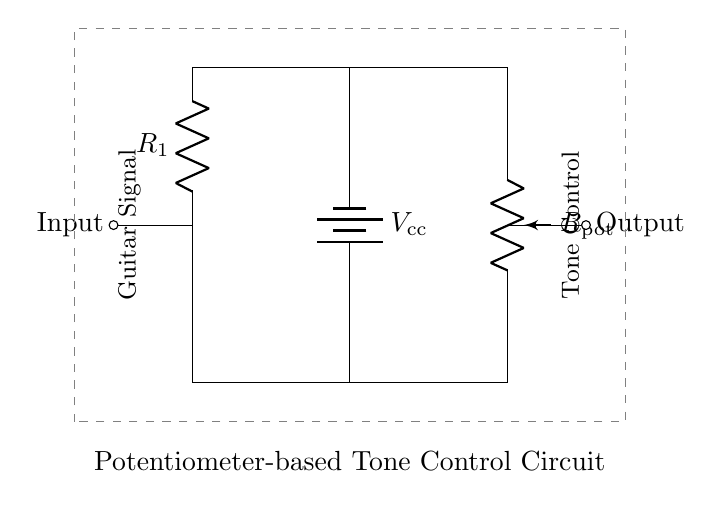What type of circuit is shown? The circuit is a voltage divider circuit. It consists of a resistor and a potentiometer which divide the input voltage to produce an output voltage based on the resistance values.
Answer: Voltage Divider What is the role of the potentiometer in this circuit? The potentiometer adjusts the resistance in the circuit, allowing for variable output voltage, which enables tone control for the guitar signal.
Answer: Tone Control How many resistive components are in the circuit? There are two resistive components, which include one resistor and one potentiometer. They work together to form the voltage divider configuration.
Answer: Two What is the labeled voltage supply in the circuit? The voltage supply is labeled as Vcc, represented by a battery providing power to the circuit. It sets the total voltage available for the voltage divider function.
Answer: Vcc What will happen if the potentiometer is turned to minimum resistance? When the potentiometer is at minimum resistance, the output voltage will be closer to the input voltage, allowing more of the guitar signal to pass through without attenuation.
Answer: Higher Voltage What is the output connection point in the circuit? The output connection point is located on the right side of the potentiometer, where the divided voltage is taken off for use in the guitar's tone control circuit.
Answer: Output 